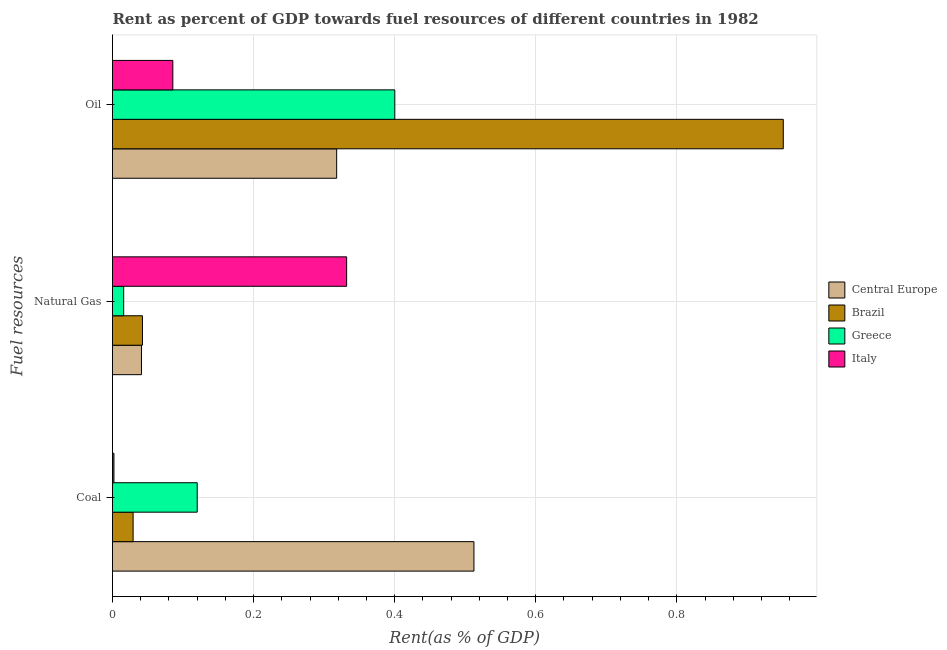How many different coloured bars are there?
Keep it short and to the point. 4. How many groups of bars are there?
Make the answer very short. 3. Are the number of bars per tick equal to the number of legend labels?
Your response must be concise. Yes. How many bars are there on the 1st tick from the top?
Provide a short and direct response. 4. What is the label of the 3rd group of bars from the top?
Your answer should be very brief. Coal. What is the rent towards oil in Greece?
Ensure brevity in your answer.  0.4. Across all countries, what is the maximum rent towards natural gas?
Offer a terse response. 0.33. Across all countries, what is the minimum rent towards natural gas?
Make the answer very short. 0.02. In which country was the rent towards coal maximum?
Provide a succinct answer. Central Europe. In which country was the rent towards natural gas minimum?
Your answer should be compact. Greece. What is the total rent towards oil in the graph?
Your answer should be compact. 1.75. What is the difference between the rent towards natural gas in Italy and that in Central Europe?
Your answer should be very brief. 0.29. What is the difference between the rent towards coal in Italy and the rent towards natural gas in Greece?
Provide a succinct answer. -0.01. What is the average rent towards oil per country?
Your response must be concise. 0.44. What is the difference between the rent towards coal and rent towards oil in Greece?
Provide a short and direct response. -0.28. In how many countries, is the rent towards natural gas greater than 0.52 %?
Provide a short and direct response. 0. What is the ratio of the rent towards oil in Brazil to that in Greece?
Give a very brief answer. 2.38. Is the difference between the rent towards natural gas in Greece and Italy greater than the difference between the rent towards coal in Greece and Italy?
Offer a terse response. No. What is the difference between the highest and the second highest rent towards coal?
Provide a succinct answer. 0.39. What is the difference between the highest and the lowest rent towards natural gas?
Offer a very short reply. 0.32. What does the 1st bar from the top in Coal represents?
Provide a succinct answer. Italy. What does the 2nd bar from the bottom in Natural Gas represents?
Your answer should be very brief. Brazil. Is it the case that in every country, the sum of the rent towards coal and rent towards natural gas is greater than the rent towards oil?
Your answer should be very brief. No. Are all the bars in the graph horizontal?
Make the answer very short. Yes. How many countries are there in the graph?
Your answer should be compact. 4. Does the graph contain any zero values?
Your response must be concise. No. Does the graph contain grids?
Offer a terse response. Yes. Where does the legend appear in the graph?
Make the answer very short. Center right. What is the title of the graph?
Provide a succinct answer. Rent as percent of GDP towards fuel resources of different countries in 1982. Does "Thailand" appear as one of the legend labels in the graph?
Ensure brevity in your answer.  No. What is the label or title of the X-axis?
Give a very brief answer. Rent(as % of GDP). What is the label or title of the Y-axis?
Make the answer very short. Fuel resources. What is the Rent(as % of GDP) of Central Europe in Coal?
Your answer should be compact. 0.51. What is the Rent(as % of GDP) of Brazil in Coal?
Your answer should be very brief. 0.03. What is the Rent(as % of GDP) in Greece in Coal?
Your response must be concise. 0.12. What is the Rent(as % of GDP) of Italy in Coal?
Give a very brief answer. 0. What is the Rent(as % of GDP) in Central Europe in Natural Gas?
Provide a succinct answer. 0.04. What is the Rent(as % of GDP) in Brazil in Natural Gas?
Offer a terse response. 0.04. What is the Rent(as % of GDP) of Greece in Natural Gas?
Offer a terse response. 0.02. What is the Rent(as % of GDP) of Italy in Natural Gas?
Provide a succinct answer. 0.33. What is the Rent(as % of GDP) in Central Europe in Oil?
Provide a succinct answer. 0.32. What is the Rent(as % of GDP) of Brazil in Oil?
Your answer should be very brief. 0.95. What is the Rent(as % of GDP) of Greece in Oil?
Provide a succinct answer. 0.4. What is the Rent(as % of GDP) in Italy in Oil?
Offer a terse response. 0.09. Across all Fuel resources, what is the maximum Rent(as % of GDP) of Central Europe?
Ensure brevity in your answer.  0.51. Across all Fuel resources, what is the maximum Rent(as % of GDP) in Brazil?
Provide a succinct answer. 0.95. Across all Fuel resources, what is the maximum Rent(as % of GDP) of Greece?
Offer a very short reply. 0.4. Across all Fuel resources, what is the maximum Rent(as % of GDP) in Italy?
Provide a succinct answer. 0.33. Across all Fuel resources, what is the minimum Rent(as % of GDP) in Central Europe?
Ensure brevity in your answer.  0.04. Across all Fuel resources, what is the minimum Rent(as % of GDP) in Brazil?
Make the answer very short. 0.03. Across all Fuel resources, what is the minimum Rent(as % of GDP) in Greece?
Your answer should be compact. 0.02. Across all Fuel resources, what is the minimum Rent(as % of GDP) of Italy?
Your response must be concise. 0. What is the total Rent(as % of GDP) in Central Europe in the graph?
Provide a short and direct response. 0.87. What is the total Rent(as % of GDP) in Brazil in the graph?
Ensure brevity in your answer.  1.02. What is the total Rent(as % of GDP) of Greece in the graph?
Provide a succinct answer. 0.54. What is the total Rent(as % of GDP) of Italy in the graph?
Keep it short and to the point. 0.42. What is the difference between the Rent(as % of GDP) of Central Europe in Coal and that in Natural Gas?
Provide a succinct answer. 0.47. What is the difference between the Rent(as % of GDP) of Brazil in Coal and that in Natural Gas?
Your answer should be very brief. -0.01. What is the difference between the Rent(as % of GDP) in Greece in Coal and that in Natural Gas?
Keep it short and to the point. 0.1. What is the difference between the Rent(as % of GDP) of Italy in Coal and that in Natural Gas?
Offer a very short reply. -0.33. What is the difference between the Rent(as % of GDP) of Central Europe in Coal and that in Oil?
Offer a very short reply. 0.19. What is the difference between the Rent(as % of GDP) of Brazil in Coal and that in Oil?
Your answer should be very brief. -0.92. What is the difference between the Rent(as % of GDP) in Greece in Coal and that in Oil?
Offer a very short reply. -0.28. What is the difference between the Rent(as % of GDP) of Italy in Coal and that in Oil?
Provide a succinct answer. -0.08. What is the difference between the Rent(as % of GDP) in Central Europe in Natural Gas and that in Oil?
Ensure brevity in your answer.  -0.28. What is the difference between the Rent(as % of GDP) in Brazil in Natural Gas and that in Oil?
Provide a short and direct response. -0.91. What is the difference between the Rent(as % of GDP) in Greece in Natural Gas and that in Oil?
Ensure brevity in your answer.  -0.38. What is the difference between the Rent(as % of GDP) of Italy in Natural Gas and that in Oil?
Provide a succinct answer. 0.25. What is the difference between the Rent(as % of GDP) of Central Europe in Coal and the Rent(as % of GDP) of Brazil in Natural Gas?
Make the answer very short. 0.47. What is the difference between the Rent(as % of GDP) in Central Europe in Coal and the Rent(as % of GDP) in Greece in Natural Gas?
Your answer should be very brief. 0.5. What is the difference between the Rent(as % of GDP) of Central Europe in Coal and the Rent(as % of GDP) of Italy in Natural Gas?
Give a very brief answer. 0.18. What is the difference between the Rent(as % of GDP) in Brazil in Coal and the Rent(as % of GDP) in Greece in Natural Gas?
Offer a very short reply. 0.01. What is the difference between the Rent(as % of GDP) of Brazil in Coal and the Rent(as % of GDP) of Italy in Natural Gas?
Make the answer very short. -0.3. What is the difference between the Rent(as % of GDP) of Greece in Coal and the Rent(as % of GDP) of Italy in Natural Gas?
Offer a terse response. -0.21. What is the difference between the Rent(as % of GDP) of Central Europe in Coal and the Rent(as % of GDP) of Brazil in Oil?
Keep it short and to the point. -0.44. What is the difference between the Rent(as % of GDP) in Central Europe in Coal and the Rent(as % of GDP) in Greece in Oil?
Provide a succinct answer. 0.11. What is the difference between the Rent(as % of GDP) of Central Europe in Coal and the Rent(as % of GDP) of Italy in Oil?
Offer a very short reply. 0.43. What is the difference between the Rent(as % of GDP) in Brazil in Coal and the Rent(as % of GDP) in Greece in Oil?
Offer a terse response. -0.37. What is the difference between the Rent(as % of GDP) of Brazil in Coal and the Rent(as % of GDP) of Italy in Oil?
Offer a terse response. -0.06. What is the difference between the Rent(as % of GDP) of Greece in Coal and the Rent(as % of GDP) of Italy in Oil?
Offer a terse response. 0.03. What is the difference between the Rent(as % of GDP) in Central Europe in Natural Gas and the Rent(as % of GDP) in Brazil in Oil?
Your response must be concise. -0.91. What is the difference between the Rent(as % of GDP) of Central Europe in Natural Gas and the Rent(as % of GDP) of Greece in Oil?
Ensure brevity in your answer.  -0.36. What is the difference between the Rent(as % of GDP) of Central Europe in Natural Gas and the Rent(as % of GDP) of Italy in Oil?
Give a very brief answer. -0.04. What is the difference between the Rent(as % of GDP) in Brazil in Natural Gas and the Rent(as % of GDP) in Greece in Oil?
Ensure brevity in your answer.  -0.36. What is the difference between the Rent(as % of GDP) in Brazil in Natural Gas and the Rent(as % of GDP) in Italy in Oil?
Your response must be concise. -0.04. What is the difference between the Rent(as % of GDP) of Greece in Natural Gas and the Rent(as % of GDP) of Italy in Oil?
Provide a succinct answer. -0.07. What is the average Rent(as % of GDP) in Central Europe per Fuel resources?
Keep it short and to the point. 0.29. What is the average Rent(as % of GDP) of Brazil per Fuel resources?
Give a very brief answer. 0.34. What is the average Rent(as % of GDP) of Greece per Fuel resources?
Your answer should be very brief. 0.18. What is the average Rent(as % of GDP) of Italy per Fuel resources?
Provide a short and direct response. 0.14. What is the difference between the Rent(as % of GDP) in Central Europe and Rent(as % of GDP) in Brazil in Coal?
Give a very brief answer. 0.48. What is the difference between the Rent(as % of GDP) in Central Europe and Rent(as % of GDP) in Greece in Coal?
Offer a very short reply. 0.39. What is the difference between the Rent(as % of GDP) in Central Europe and Rent(as % of GDP) in Italy in Coal?
Ensure brevity in your answer.  0.51. What is the difference between the Rent(as % of GDP) in Brazil and Rent(as % of GDP) in Greece in Coal?
Keep it short and to the point. -0.09. What is the difference between the Rent(as % of GDP) in Brazil and Rent(as % of GDP) in Italy in Coal?
Offer a very short reply. 0.03. What is the difference between the Rent(as % of GDP) of Greece and Rent(as % of GDP) of Italy in Coal?
Provide a short and direct response. 0.12. What is the difference between the Rent(as % of GDP) in Central Europe and Rent(as % of GDP) in Brazil in Natural Gas?
Make the answer very short. -0. What is the difference between the Rent(as % of GDP) in Central Europe and Rent(as % of GDP) in Greece in Natural Gas?
Make the answer very short. 0.03. What is the difference between the Rent(as % of GDP) of Central Europe and Rent(as % of GDP) of Italy in Natural Gas?
Keep it short and to the point. -0.29. What is the difference between the Rent(as % of GDP) of Brazil and Rent(as % of GDP) of Greece in Natural Gas?
Give a very brief answer. 0.03. What is the difference between the Rent(as % of GDP) in Brazil and Rent(as % of GDP) in Italy in Natural Gas?
Offer a very short reply. -0.29. What is the difference between the Rent(as % of GDP) of Greece and Rent(as % of GDP) of Italy in Natural Gas?
Ensure brevity in your answer.  -0.32. What is the difference between the Rent(as % of GDP) of Central Europe and Rent(as % of GDP) of Brazil in Oil?
Provide a succinct answer. -0.63. What is the difference between the Rent(as % of GDP) of Central Europe and Rent(as % of GDP) of Greece in Oil?
Offer a terse response. -0.08. What is the difference between the Rent(as % of GDP) in Central Europe and Rent(as % of GDP) in Italy in Oil?
Keep it short and to the point. 0.23. What is the difference between the Rent(as % of GDP) of Brazil and Rent(as % of GDP) of Greece in Oil?
Keep it short and to the point. 0.55. What is the difference between the Rent(as % of GDP) of Brazil and Rent(as % of GDP) of Italy in Oil?
Your answer should be very brief. 0.87. What is the difference between the Rent(as % of GDP) in Greece and Rent(as % of GDP) in Italy in Oil?
Make the answer very short. 0.31. What is the ratio of the Rent(as % of GDP) in Central Europe in Coal to that in Natural Gas?
Make the answer very short. 12.48. What is the ratio of the Rent(as % of GDP) of Brazil in Coal to that in Natural Gas?
Keep it short and to the point. 0.69. What is the ratio of the Rent(as % of GDP) in Greece in Coal to that in Natural Gas?
Provide a short and direct response. 7.58. What is the ratio of the Rent(as % of GDP) in Italy in Coal to that in Natural Gas?
Give a very brief answer. 0.01. What is the ratio of the Rent(as % of GDP) of Central Europe in Coal to that in Oil?
Ensure brevity in your answer.  1.61. What is the ratio of the Rent(as % of GDP) of Brazil in Coal to that in Oil?
Ensure brevity in your answer.  0.03. What is the ratio of the Rent(as % of GDP) of Greece in Coal to that in Oil?
Provide a succinct answer. 0.3. What is the ratio of the Rent(as % of GDP) in Italy in Coal to that in Oil?
Give a very brief answer. 0.02. What is the ratio of the Rent(as % of GDP) in Central Europe in Natural Gas to that in Oil?
Offer a terse response. 0.13. What is the ratio of the Rent(as % of GDP) in Brazil in Natural Gas to that in Oil?
Your response must be concise. 0.04. What is the ratio of the Rent(as % of GDP) in Greece in Natural Gas to that in Oil?
Your answer should be very brief. 0.04. What is the ratio of the Rent(as % of GDP) of Italy in Natural Gas to that in Oil?
Offer a very short reply. 3.88. What is the difference between the highest and the second highest Rent(as % of GDP) in Central Europe?
Provide a short and direct response. 0.19. What is the difference between the highest and the second highest Rent(as % of GDP) of Brazil?
Ensure brevity in your answer.  0.91. What is the difference between the highest and the second highest Rent(as % of GDP) of Greece?
Your answer should be very brief. 0.28. What is the difference between the highest and the second highest Rent(as % of GDP) of Italy?
Make the answer very short. 0.25. What is the difference between the highest and the lowest Rent(as % of GDP) of Central Europe?
Your response must be concise. 0.47. What is the difference between the highest and the lowest Rent(as % of GDP) in Brazil?
Provide a succinct answer. 0.92. What is the difference between the highest and the lowest Rent(as % of GDP) of Greece?
Offer a terse response. 0.38. What is the difference between the highest and the lowest Rent(as % of GDP) of Italy?
Keep it short and to the point. 0.33. 